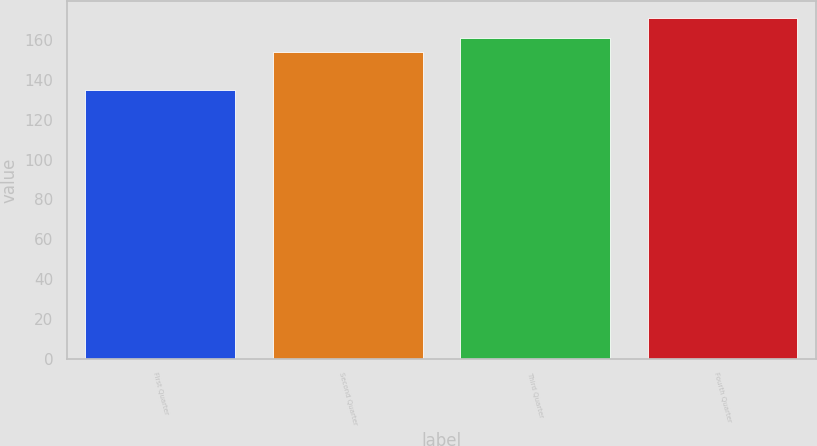Convert chart. <chart><loc_0><loc_0><loc_500><loc_500><bar_chart><fcel>First Quarter<fcel>Second Quarter<fcel>Third Quarter<fcel>Fourth Quarter<nl><fcel>134.87<fcel>153.93<fcel>161.27<fcel>170.99<nl></chart> 